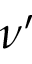Convert formula to latex. <formula><loc_0><loc_0><loc_500><loc_500>\nu ^ { \prime }</formula> 